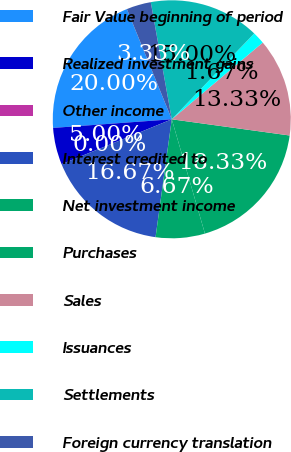<chart> <loc_0><loc_0><loc_500><loc_500><pie_chart><fcel>Fair Value beginning of period<fcel>Realized investment gains<fcel>Other income<fcel>Interest credited to<fcel>Net investment income<fcel>Purchases<fcel>Sales<fcel>Issuances<fcel>Settlements<fcel>Foreign currency translation<nl><fcel>20.0%<fcel>5.0%<fcel>0.0%<fcel>16.67%<fcel>6.67%<fcel>18.33%<fcel>13.33%<fcel>1.67%<fcel>15.0%<fcel>3.33%<nl></chart> 